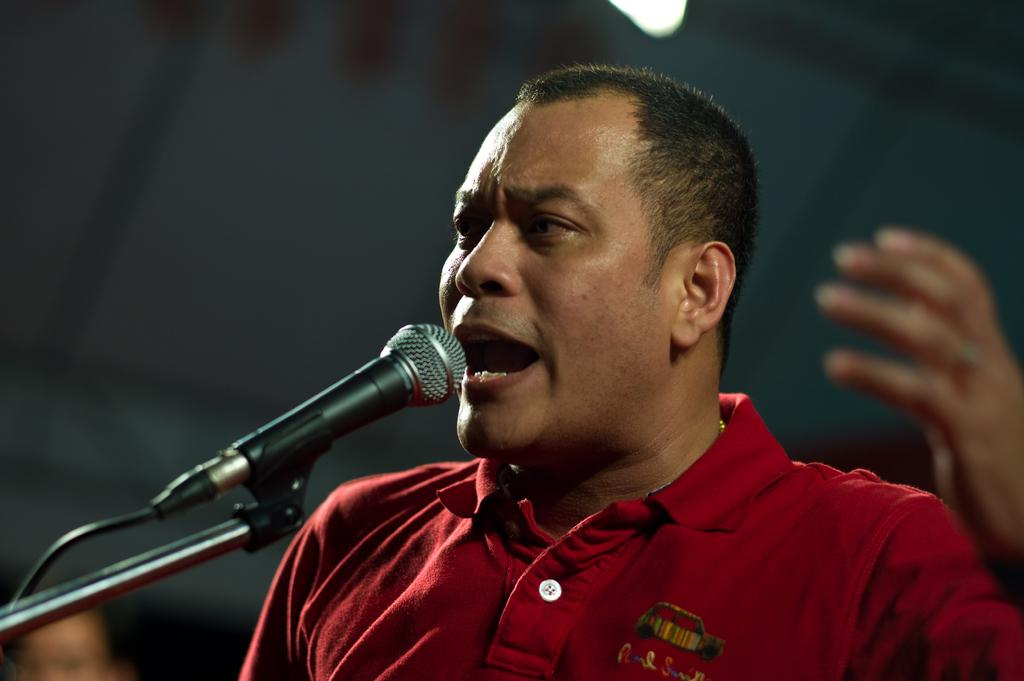Who is the main subject in the image? There is a man in the middle of the image. What object is in front of the man? There is a mic in front of the man. Can you describe the background of the image? The background of the image is blurred. How many trucks are visible in the image? There are no trucks visible in the image. What type of invention is the man holding in the image? The man is not holding any invention in the image; he is standing in front of a mic. 